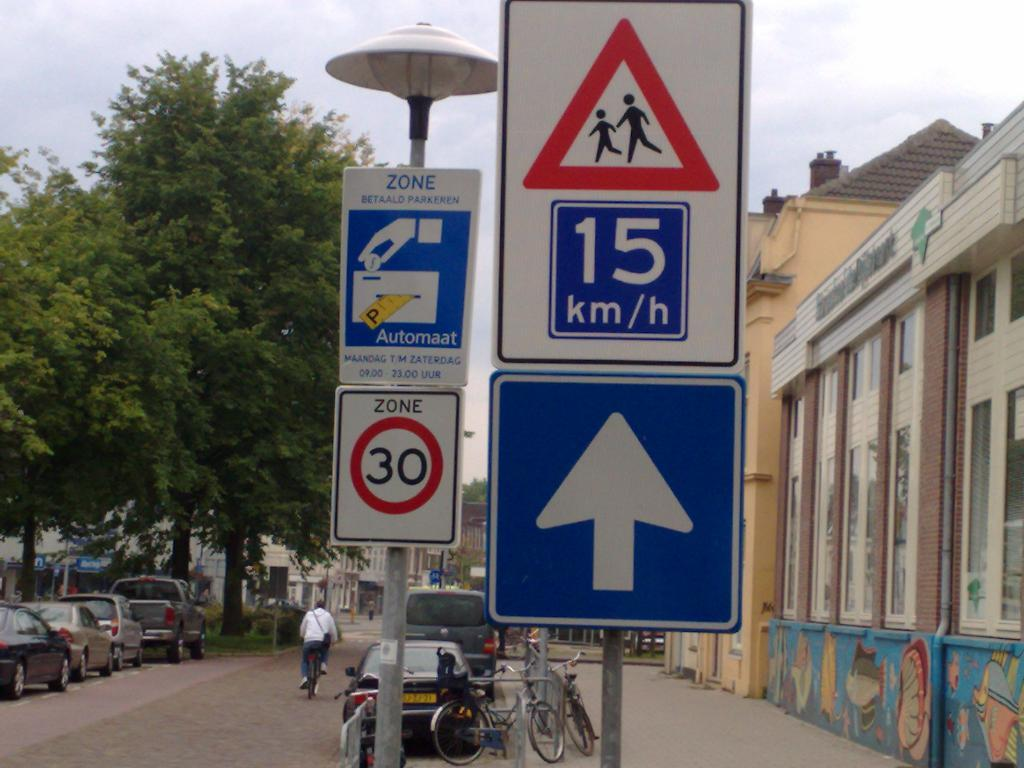<image>
Share a concise interpretation of the image provided. A sign says that the limit is 15 kilometers per hour. 